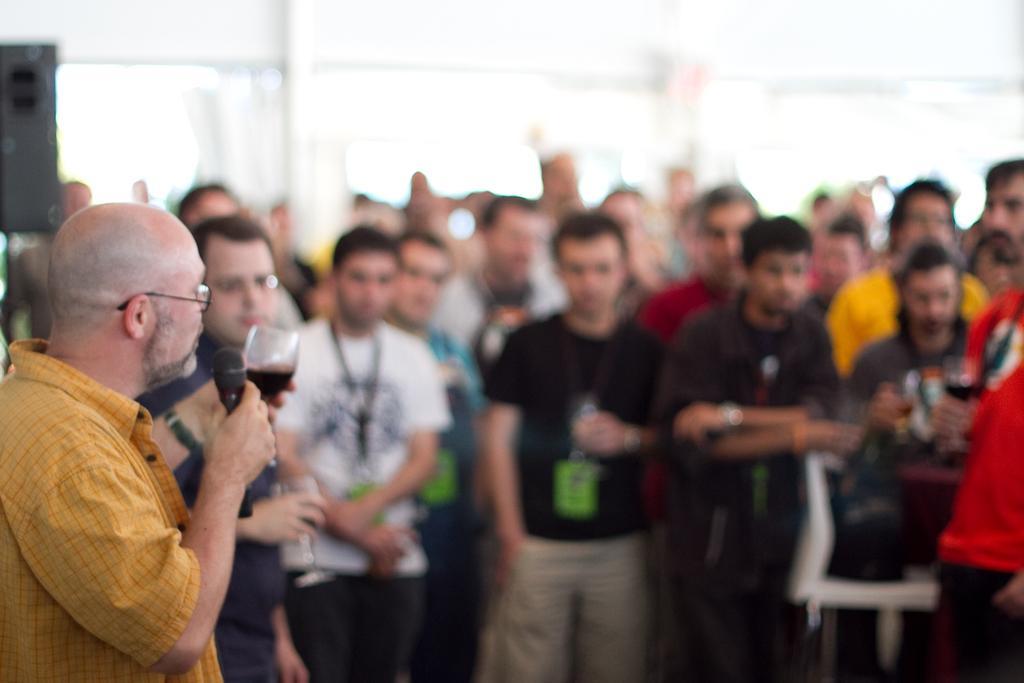How would you summarize this image in a sentence or two? In the center of the image we can see people standing. The man standing on the left is holding a mic and a wine glass in his hands. In the background there is a wall. 